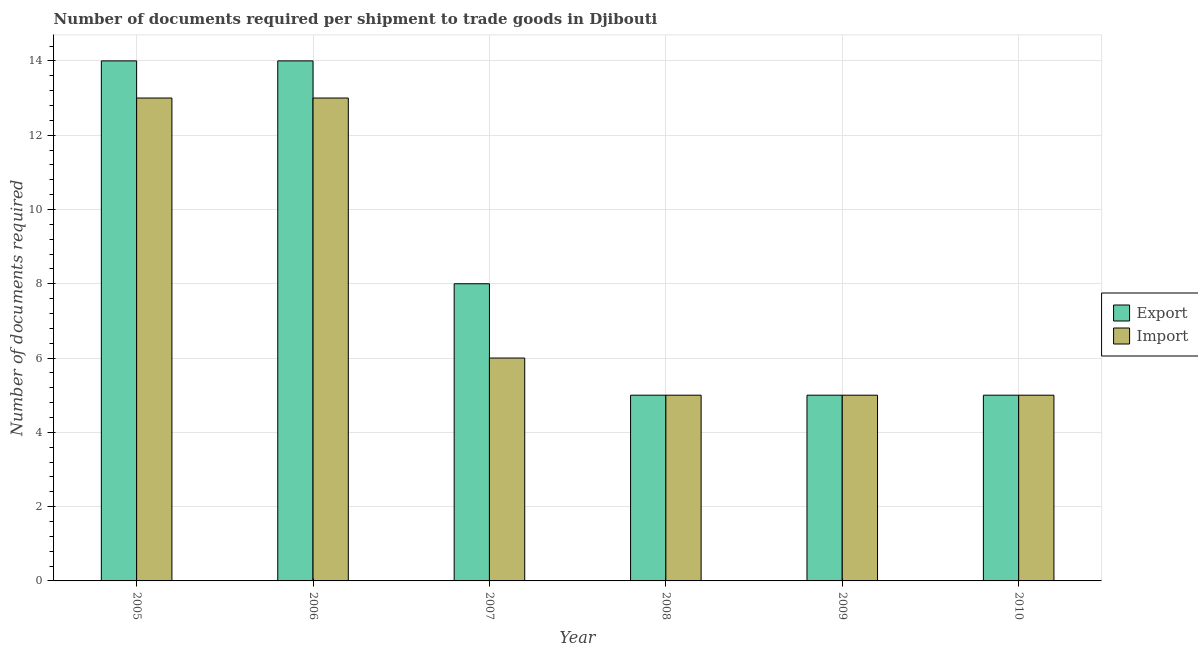Are the number of bars per tick equal to the number of legend labels?
Your answer should be very brief. Yes. Are the number of bars on each tick of the X-axis equal?
Your response must be concise. Yes. How many bars are there on the 5th tick from the left?
Provide a succinct answer. 2. How many bars are there on the 3rd tick from the right?
Offer a very short reply. 2. What is the number of documents required to import goods in 2006?
Your answer should be very brief. 13. Across all years, what is the maximum number of documents required to export goods?
Make the answer very short. 14. Across all years, what is the minimum number of documents required to import goods?
Provide a short and direct response. 5. What is the total number of documents required to export goods in the graph?
Keep it short and to the point. 51. What is the average number of documents required to export goods per year?
Make the answer very short. 8.5. In the year 2009, what is the difference between the number of documents required to export goods and number of documents required to import goods?
Offer a very short reply. 0. Is the number of documents required to import goods in 2005 less than that in 2006?
Provide a short and direct response. No. What is the difference between the highest and the second highest number of documents required to export goods?
Keep it short and to the point. 0. What is the difference between the highest and the lowest number of documents required to export goods?
Offer a terse response. 9. In how many years, is the number of documents required to import goods greater than the average number of documents required to import goods taken over all years?
Make the answer very short. 2. What does the 1st bar from the left in 2007 represents?
Keep it short and to the point. Export. What does the 1st bar from the right in 2005 represents?
Ensure brevity in your answer.  Import. Are all the bars in the graph horizontal?
Ensure brevity in your answer.  No. Where does the legend appear in the graph?
Make the answer very short. Center right. What is the title of the graph?
Give a very brief answer. Number of documents required per shipment to trade goods in Djibouti. Does "Investments" appear as one of the legend labels in the graph?
Your answer should be compact. No. What is the label or title of the X-axis?
Offer a very short reply. Year. What is the label or title of the Y-axis?
Your response must be concise. Number of documents required. What is the Number of documents required in Export in 2005?
Give a very brief answer. 14. What is the Number of documents required in Import in 2005?
Offer a very short reply. 13. What is the Number of documents required in Export in 2006?
Your answer should be compact. 14. What is the Number of documents required in Export in 2007?
Offer a terse response. 8. What is the Number of documents required of Export in 2008?
Keep it short and to the point. 5. What is the Number of documents required in Export in 2009?
Make the answer very short. 5. What is the Number of documents required of Import in 2010?
Your answer should be very brief. 5. Across all years, what is the minimum Number of documents required in Export?
Provide a succinct answer. 5. Across all years, what is the minimum Number of documents required of Import?
Offer a terse response. 5. What is the total Number of documents required of Export in the graph?
Make the answer very short. 51. What is the total Number of documents required of Import in the graph?
Your answer should be compact. 47. What is the difference between the Number of documents required of Export in 2005 and that in 2006?
Your response must be concise. 0. What is the difference between the Number of documents required in Import in 2005 and that in 2006?
Your response must be concise. 0. What is the difference between the Number of documents required of Export in 2005 and that in 2007?
Make the answer very short. 6. What is the difference between the Number of documents required of Import in 2005 and that in 2007?
Ensure brevity in your answer.  7. What is the difference between the Number of documents required of Import in 2005 and that in 2008?
Give a very brief answer. 8. What is the difference between the Number of documents required of Export in 2005 and that in 2009?
Provide a succinct answer. 9. What is the difference between the Number of documents required in Export in 2005 and that in 2010?
Offer a terse response. 9. What is the difference between the Number of documents required in Import in 2005 and that in 2010?
Your response must be concise. 8. What is the difference between the Number of documents required of Export in 2006 and that in 2007?
Offer a terse response. 6. What is the difference between the Number of documents required in Import in 2006 and that in 2007?
Your answer should be very brief. 7. What is the difference between the Number of documents required in Export in 2006 and that in 2009?
Make the answer very short. 9. What is the difference between the Number of documents required of Import in 2006 and that in 2009?
Your response must be concise. 8. What is the difference between the Number of documents required in Import in 2007 and that in 2008?
Provide a succinct answer. 1. What is the difference between the Number of documents required of Import in 2007 and that in 2009?
Your answer should be very brief. 1. What is the difference between the Number of documents required of Import in 2007 and that in 2010?
Provide a short and direct response. 1. What is the difference between the Number of documents required in Export in 2008 and that in 2009?
Your answer should be very brief. 0. What is the difference between the Number of documents required in Export in 2008 and that in 2010?
Your answer should be compact. 0. What is the difference between the Number of documents required of Export in 2009 and that in 2010?
Your response must be concise. 0. What is the difference between the Number of documents required of Export in 2005 and the Number of documents required of Import in 2006?
Make the answer very short. 1. What is the difference between the Number of documents required of Export in 2005 and the Number of documents required of Import in 2007?
Your answer should be very brief. 8. What is the difference between the Number of documents required of Export in 2006 and the Number of documents required of Import in 2007?
Your response must be concise. 8. What is the difference between the Number of documents required of Export in 2007 and the Number of documents required of Import in 2009?
Give a very brief answer. 3. What is the difference between the Number of documents required in Export in 2008 and the Number of documents required in Import in 2009?
Keep it short and to the point. 0. What is the difference between the Number of documents required in Export in 2008 and the Number of documents required in Import in 2010?
Ensure brevity in your answer.  0. What is the average Number of documents required in Import per year?
Give a very brief answer. 7.83. In the year 2006, what is the difference between the Number of documents required in Export and Number of documents required in Import?
Your answer should be very brief. 1. In the year 2008, what is the difference between the Number of documents required of Export and Number of documents required of Import?
Offer a terse response. 0. In the year 2010, what is the difference between the Number of documents required of Export and Number of documents required of Import?
Give a very brief answer. 0. What is the ratio of the Number of documents required in Import in 2005 to that in 2006?
Your answer should be compact. 1. What is the ratio of the Number of documents required of Import in 2005 to that in 2007?
Give a very brief answer. 2.17. What is the ratio of the Number of documents required of Export in 2005 to that in 2008?
Offer a terse response. 2.8. What is the ratio of the Number of documents required in Import in 2005 to that in 2008?
Offer a terse response. 2.6. What is the ratio of the Number of documents required in Export in 2005 to that in 2009?
Your response must be concise. 2.8. What is the ratio of the Number of documents required in Import in 2005 to that in 2009?
Make the answer very short. 2.6. What is the ratio of the Number of documents required in Export in 2005 to that in 2010?
Your response must be concise. 2.8. What is the ratio of the Number of documents required of Import in 2005 to that in 2010?
Your response must be concise. 2.6. What is the ratio of the Number of documents required of Import in 2006 to that in 2007?
Ensure brevity in your answer.  2.17. What is the ratio of the Number of documents required in Export in 2006 to that in 2008?
Provide a short and direct response. 2.8. What is the ratio of the Number of documents required in Export in 2006 to that in 2009?
Provide a succinct answer. 2.8. What is the ratio of the Number of documents required of Import in 2006 to that in 2009?
Your answer should be compact. 2.6. What is the ratio of the Number of documents required in Export in 2006 to that in 2010?
Provide a succinct answer. 2.8. What is the ratio of the Number of documents required in Export in 2007 to that in 2010?
Your answer should be very brief. 1.6. What is the ratio of the Number of documents required of Import in 2009 to that in 2010?
Give a very brief answer. 1. What is the difference between the highest and the second highest Number of documents required in Export?
Keep it short and to the point. 0. What is the difference between the highest and the second highest Number of documents required of Import?
Make the answer very short. 0. What is the difference between the highest and the lowest Number of documents required of Export?
Offer a very short reply. 9. 